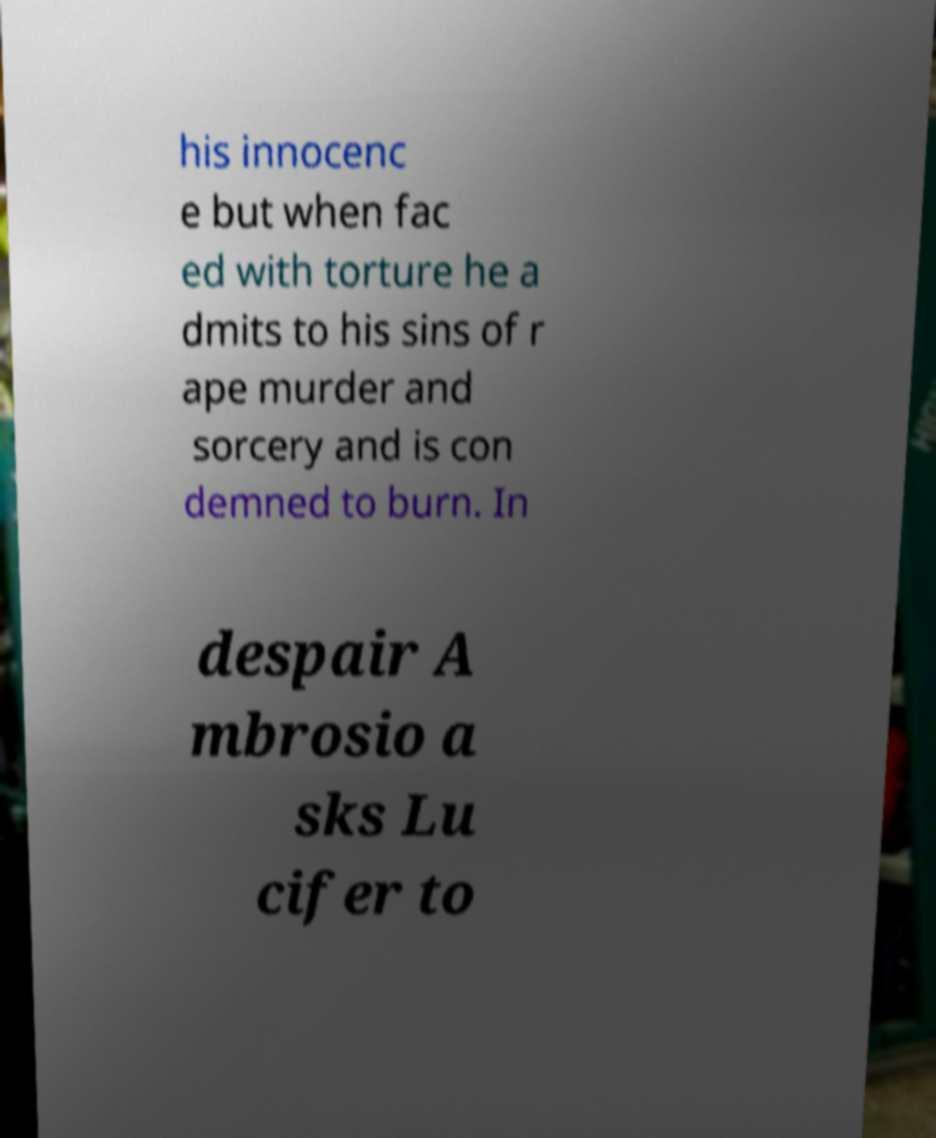Please read and relay the text visible in this image. What does it say? his innocenc e but when fac ed with torture he a dmits to his sins of r ape murder and sorcery and is con demned to burn. In despair A mbrosio a sks Lu cifer to 